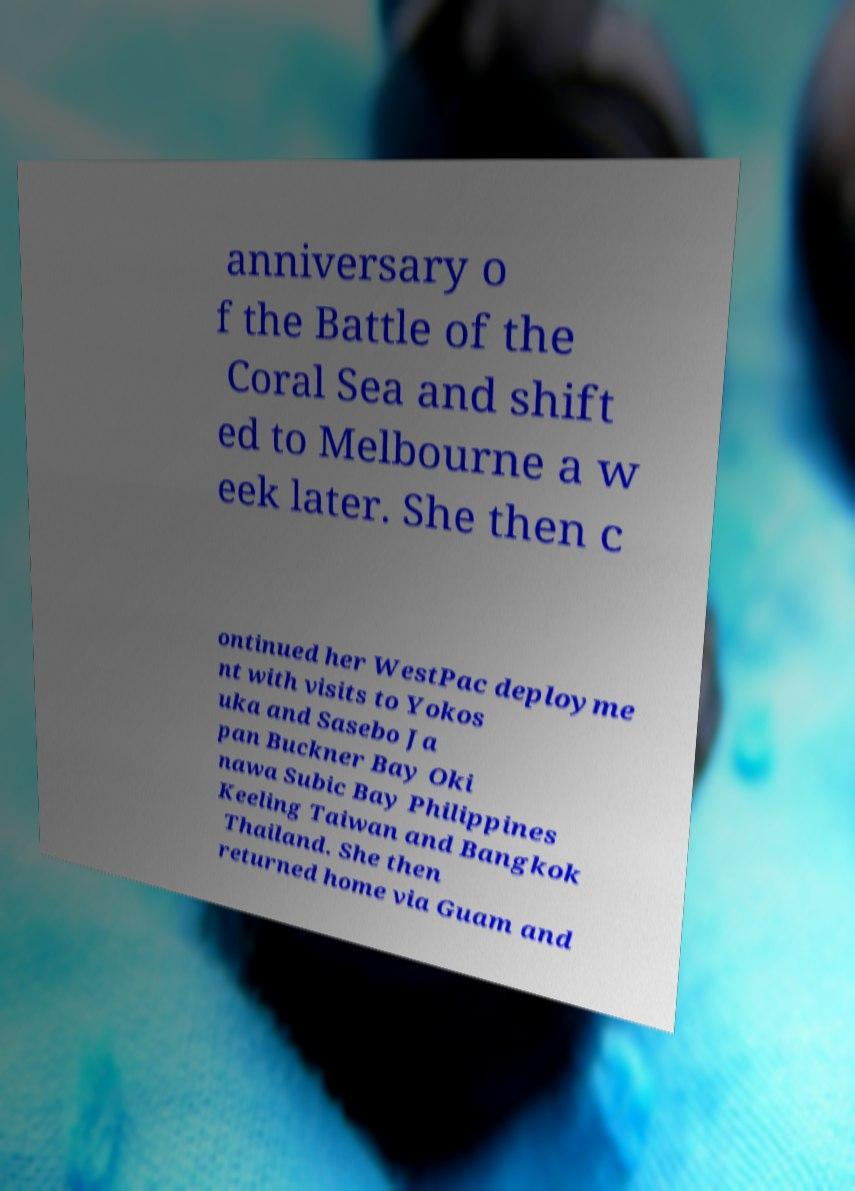Please read and relay the text visible in this image. What does it say? anniversary o f the Battle of the Coral Sea and shift ed to Melbourne a w eek later. She then c ontinued her WestPac deployme nt with visits to Yokos uka and Sasebo Ja pan Buckner Bay Oki nawa Subic Bay Philippines Keeling Taiwan and Bangkok Thailand. She then returned home via Guam and 